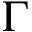Convert formula to latex. <formula><loc_0><loc_0><loc_500><loc_500>\Gamma</formula> 